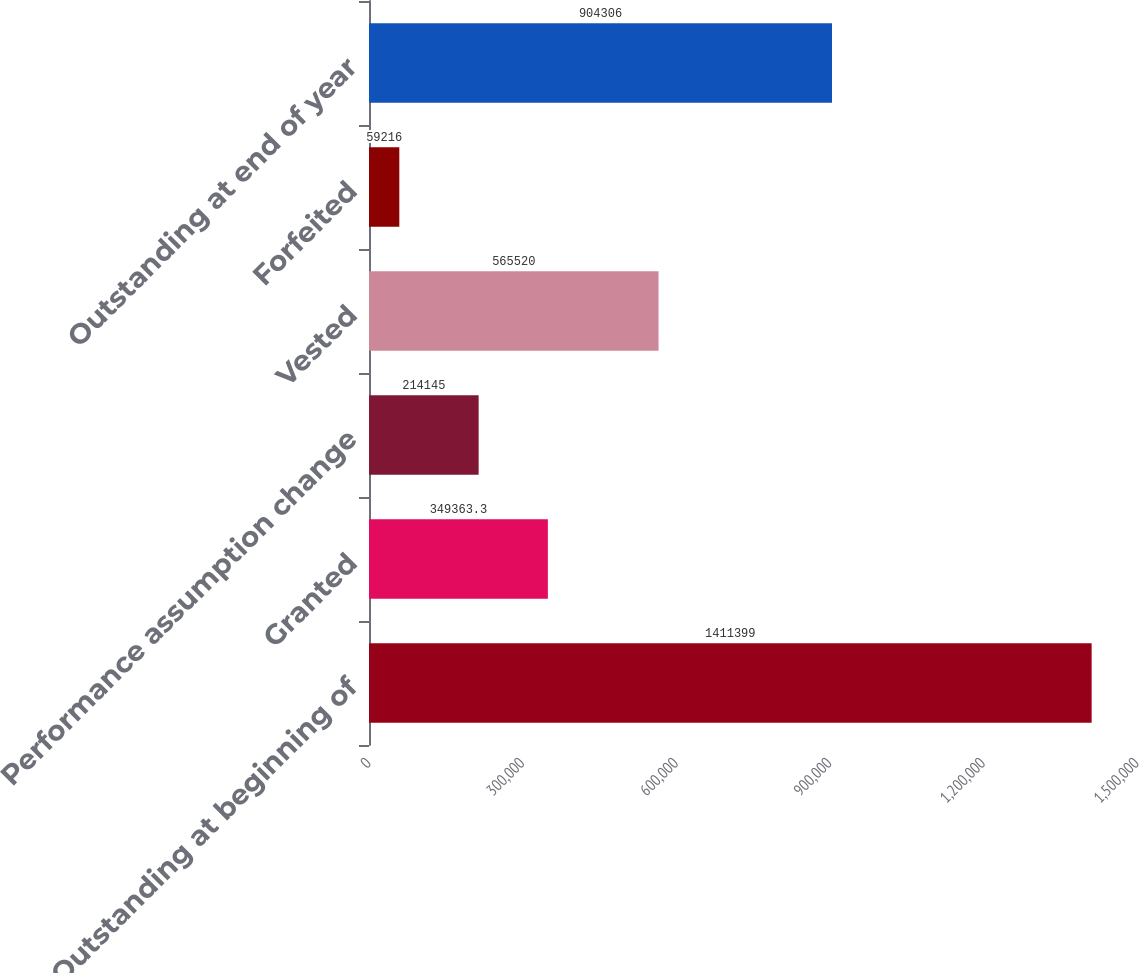Convert chart. <chart><loc_0><loc_0><loc_500><loc_500><bar_chart><fcel>Outstanding at beginning of<fcel>Granted<fcel>Performance assumption change<fcel>Vested<fcel>Forfeited<fcel>Outstanding at end of year<nl><fcel>1.4114e+06<fcel>349363<fcel>214145<fcel>565520<fcel>59216<fcel>904306<nl></chart> 